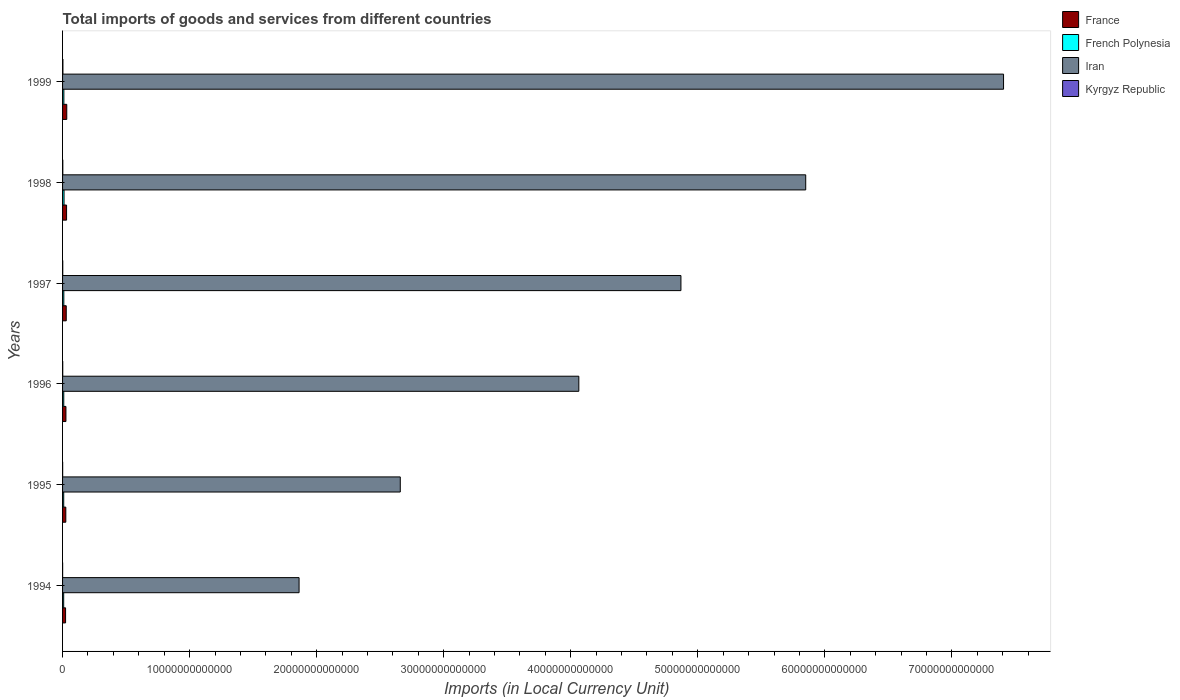Are the number of bars on each tick of the Y-axis equal?
Provide a succinct answer. Yes. How many bars are there on the 4th tick from the top?
Keep it short and to the point. 4. How many bars are there on the 3rd tick from the bottom?
Make the answer very short. 4. What is the Amount of goods and services imports in Iran in 1994?
Offer a terse response. 1.86e+13. Across all years, what is the maximum Amount of goods and services imports in Iran?
Offer a very short reply. 7.41e+13. Across all years, what is the minimum Amount of goods and services imports in Iran?
Provide a succinct answer. 1.86e+13. In which year was the Amount of goods and services imports in Iran maximum?
Provide a short and direct response. 1999. What is the total Amount of goods and services imports in Kyrgyz Republic in the graph?
Keep it short and to the point. 8.67e+1. What is the difference between the Amount of goods and services imports in Iran in 1995 and that in 1999?
Offer a terse response. -4.75e+13. What is the difference between the Amount of goods and services imports in French Polynesia in 1997 and the Amount of goods and services imports in Kyrgyz Republic in 1998?
Keep it short and to the point. 7.95e+1. What is the average Amount of goods and services imports in French Polynesia per year?
Make the answer very short. 9.87e+1. In the year 1995, what is the difference between the Amount of goods and services imports in Kyrgyz Republic and Amount of goods and services imports in Iran?
Offer a terse response. -2.66e+13. What is the ratio of the Amount of goods and services imports in Kyrgyz Republic in 1995 to that in 1999?
Give a very brief answer. 0.25. What is the difference between the highest and the second highest Amount of goods and services imports in Kyrgyz Republic?
Ensure brevity in your answer.  7.95e+09. What is the difference between the highest and the lowest Amount of goods and services imports in France?
Make the answer very short. 9.37e+1. What does the 1st bar from the top in 1998 represents?
Give a very brief answer. Kyrgyz Republic. What does the 2nd bar from the bottom in 1996 represents?
Provide a succinct answer. French Polynesia. Is it the case that in every year, the sum of the Amount of goods and services imports in Kyrgyz Republic and Amount of goods and services imports in Iran is greater than the Amount of goods and services imports in French Polynesia?
Provide a short and direct response. Yes. How many bars are there?
Provide a succinct answer. 24. Are all the bars in the graph horizontal?
Offer a very short reply. Yes. What is the difference between two consecutive major ticks on the X-axis?
Make the answer very short. 1.00e+13. Are the values on the major ticks of X-axis written in scientific E-notation?
Provide a short and direct response. No. How many legend labels are there?
Ensure brevity in your answer.  4. How are the legend labels stacked?
Your answer should be very brief. Vertical. What is the title of the graph?
Give a very brief answer. Total imports of goods and services from different countries. What is the label or title of the X-axis?
Make the answer very short. Imports (in Local Currency Unit). What is the label or title of the Y-axis?
Offer a very short reply. Years. What is the Imports (in Local Currency Unit) of France in 1994?
Your response must be concise. 2.37e+11. What is the Imports (in Local Currency Unit) in French Polynesia in 1994?
Your answer should be very brief. 8.79e+1. What is the Imports (in Local Currency Unit) in Iran in 1994?
Offer a terse response. 1.86e+13. What is the Imports (in Local Currency Unit) in Kyrgyz Republic in 1994?
Offer a very short reply. 4.82e+09. What is the Imports (in Local Currency Unit) in France in 1995?
Your response must be concise. 2.56e+11. What is the Imports (in Local Currency Unit) in French Polynesia in 1995?
Make the answer very short. 9.12e+1. What is the Imports (in Local Currency Unit) of Iran in 1995?
Ensure brevity in your answer.  2.66e+13. What is the Imports (in Local Currency Unit) in Kyrgyz Republic in 1995?
Provide a short and direct response. 6.84e+09. What is the Imports (in Local Currency Unit) of France in 1996?
Offer a terse response. 2.66e+11. What is the Imports (in Local Currency Unit) of French Polynesia in 1996?
Provide a short and direct response. 9.45e+1. What is the Imports (in Local Currency Unit) in Iran in 1996?
Offer a very short reply. 4.06e+13. What is the Imports (in Local Currency Unit) of Kyrgyz Republic in 1996?
Ensure brevity in your answer.  1.32e+1. What is the Imports (in Local Currency Unit) in France in 1997?
Provide a short and direct response. 2.90e+11. What is the Imports (in Local Currency Unit) in French Polynesia in 1997?
Your response must be concise. 9.93e+1. What is the Imports (in Local Currency Unit) in Iran in 1997?
Keep it short and to the point. 4.87e+13. What is the Imports (in Local Currency Unit) of Kyrgyz Republic in 1997?
Offer a terse response. 1.42e+1. What is the Imports (in Local Currency Unit) of France in 1998?
Ensure brevity in your answer.  3.15e+11. What is the Imports (in Local Currency Unit) in French Polynesia in 1998?
Provide a succinct answer. 1.16e+11. What is the Imports (in Local Currency Unit) of Iran in 1998?
Give a very brief answer. 5.85e+13. What is the Imports (in Local Currency Unit) of Kyrgyz Republic in 1998?
Give a very brief answer. 1.98e+1. What is the Imports (in Local Currency Unit) in France in 1999?
Provide a succinct answer. 3.31e+11. What is the Imports (in Local Currency Unit) of French Polynesia in 1999?
Your response must be concise. 1.03e+11. What is the Imports (in Local Currency Unit) of Iran in 1999?
Provide a succinct answer. 7.41e+13. What is the Imports (in Local Currency Unit) of Kyrgyz Republic in 1999?
Your response must be concise. 2.78e+1. Across all years, what is the maximum Imports (in Local Currency Unit) in France?
Give a very brief answer. 3.31e+11. Across all years, what is the maximum Imports (in Local Currency Unit) in French Polynesia?
Provide a short and direct response. 1.16e+11. Across all years, what is the maximum Imports (in Local Currency Unit) in Iran?
Provide a short and direct response. 7.41e+13. Across all years, what is the maximum Imports (in Local Currency Unit) of Kyrgyz Republic?
Ensure brevity in your answer.  2.78e+1. Across all years, what is the minimum Imports (in Local Currency Unit) in France?
Your answer should be compact. 2.37e+11. Across all years, what is the minimum Imports (in Local Currency Unit) of French Polynesia?
Keep it short and to the point. 8.79e+1. Across all years, what is the minimum Imports (in Local Currency Unit) in Iran?
Offer a terse response. 1.86e+13. Across all years, what is the minimum Imports (in Local Currency Unit) in Kyrgyz Republic?
Ensure brevity in your answer.  4.82e+09. What is the total Imports (in Local Currency Unit) in France in the graph?
Your response must be concise. 1.70e+12. What is the total Imports (in Local Currency Unit) of French Polynesia in the graph?
Give a very brief answer. 5.92e+11. What is the total Imports (in Local Currency Unit) in Iran in the graph?
Your answer should be compact. 2.67e+14. What is the total Imports (in Local Currency Unit) of Kyrgyz Republic in the graph?
Your answer should be compact. 8.67e+1. What is the difference between the Imports (in Local Currency Unit) of France in 1994 and that in 1995?
Make the answer very short. -1.82e+1. What is the difference between the Imports (in Local Currency Unit) in French Polynesia in 1994 and that in 1995?
Provide a succinct answer. -3.31e+09. What is the difference between the Imports (in Local Currency Unit) in Iran in 1994 and that in 1995?
Give a very brief answer. -7.97e+12. What is the difference between the Imports (in Local Currency Unit) in Kyrgyz Republic in 1994 and that in 1995?
Offer a very short reply. -2.02e+09. What is the difference between the Imports (in Local Currency Unit) of France in 1994 and that in 1996?
Provide a succinct answer. -2.84e+1. What is the difference between the Imports (in Local Currency Unit) of French Polynesia in 1994 and that in 1996?
Offer a very short reply. -6.61e+09. What is the difference between the Imports (in Local Currency Unit) of Iran in 1994 and that in 1996?
Your answer should be very brief. -2.20e+13. What is the difference between the Imports (in Local Currency Unit) of Kyrgyz Republic in 1994 and that in 1996?
Offer a very short reply. -8.42e+09. What is the difference between the Imports (in Local Currency Unit) of France in 1994 and that in 1997?
Your answer should be compact. -5.29e+1. What is the difference between the Imports (in Local Currency Unit) of French Polynesia in 1994 and that in 1997?
Provide a succinct answer. -1.14e+1. What is the difference between the Imports (in Local Currency Unit) of Iran in 1994 and that in 1997?
Offer a very short reply. -3.01e+13. What is the difference between the Imports (in Local Currency Unit) of Kyrgyz Republic in 1994 and that in 1997?
Provide a short and direct response. -9.36e+09. What is the difference between the Imports (in Local Currency Unit) in France in 1994 and that in 1998?
Offer a terse response. -7.79e+1. What is the difference between the Imports (in Local Currency Unit) in French Polynesia in 1994 and that in 1998?
Your response must be concise. -2.85e+1. What is the difference between the Imports (in Local Currency Unit) of Iran in 1994 and that in 1998?
Provide a short and direct response. -3.99e+13. What is the difference between the Imports (in Local Currency Unit) of Kyrgyz Republic in 1994 and that in 1998?
Make the answer very short. -1.50e+1. What is the difference between the Imports (in Local Currency Unit) in France in 1994 and that in 1999?
Give a very brief answer. -9.37e+1. What is the difference between the Imports (in Local Currency Unit) of French Polynesia in 1994 and that in 1999?
Make the answer very short. -1.51e+1. What is the difference between the Imports (in Local Currency Unit) of Iran in 1994 and that in 1999?
Keep it short and to the point. -5.54e+13. What is the difference between the Imports (in Local Currency Unit) in Kyrgyz Republic in 1994 and that in 1999?
Give a very brief answer. -2.30e+1. What is the difference between the Imports (in Local Currency Unit) in France in 1995 and that in 1996?
Offer a terse response. -1.02e+1. What is the difference between the Imports (in Local Currency Unit) in French Polynesia in 1995 and that in 1996?
Give a very brief answer. -3.31e+09. What is the difference between the Imports (in Local Currency Unit) in Iran in 1995 and that in 1996?
Provide a short and direct response. -1.41e+13. What is the difference between the Imports (in Local Currency Unit) in Kyrgyz Republic in 1995 and that in 1996?
Keep it short and to the point. -6.40e+09. What is the difference between the Imports (in Local Currency Unit) of France in 1995 and that in 1997?
Offer a very short reply. -3.47e+1. What is the difference between the Imports (in Local Currency Unit) of French Polynesia in 1995 and that in 1997?
Ensure brevity in your answer.  -8.13e+09. What is the difference between the Imports (in Local Currency Unit) of Iran in 1995 and that in 1997?
Offer a terse response. -2.21e+13. What is the difference between the Imports (in Local Currency Unit) in Kyrgyz Republic in 1995 and that in 1997?
Provide a short and direct response. -7.33e+09. What is the difference between the Imports (in Local Currency Unit) of France in 1995 and that in 1998?
Make the answer very short. -5.98e+1. What is the difference between the Imports (in Local Currency Unit) of French Polynesia in 1995 and that in 1998?
Your answer should be compact. -2.52e+1. What is the difference between the Imports (in Local Currency Unit) in Iran in 1995 and that in 1998?
Offer a terse response. -3.19e+13. What is the difference between the Imports (in Local Currency Unit) in Kyrgyz Republic in 1995 and that in 1998?
Give a very brief answer. -1.30e+1. What is the difference between the Imports (in Local Currency Unit) of France in 1995 and that in 1999?
Offer a very short reply. -7.55e+1. What is the difference between the Imports (in Local Currency Unit) in French Polynesia in 1995 and that in 1999?
Make the answer very short. -1.18e+1. What is the difference between the Imports (in Local Currency Unit) of Iran in 1995 and that in 1999?
Provide a succinct answer. -4.75e+13. What is the difference between the Imports (in Local Currency Unit) of Kyrgyz Republic in 1995 and that in 1999?
Ensure brevity in your answer.  -2.09e+1. What is the difference between the Imports (in Local Currency Unit) of France in 1996 and that in 1997?
Give a very brief answer. -2.45e+1. What is the difference between the Imports (in Local Currency Unit) in French Polynesia in 1996 and that in 1997?
Provide a short and direct response. -4.82e+09. What is the difference between the Imports (in Local Currency Unit) in Iran in 1996 and that in 1997?
Ensure brevity in your answer.  -8.04e+12. What is the difference between the Imports (in Local Currency Unit) in Kyrgyz Republic in 1996 and that in 1997?
Provide a short and direct response. -9.40e+08. What is the difference between the Imports (in Local Currency Unit) in France in 1996 and that in 1998?
Give a very brief answer. -4.96e+1. What is the difference between the Imports (in Local Currency Unit) in French Polynesia in 1996 and that in 1998?
Your answer should be very brief. -2.19e+1. What is the difference between the Imports (in Local Currency Unit) of Iran in 1996 and that in 1998?
Make the answer very short. -1.79e+13. What is the difference between the Imports (in Local Currency Unit) of Kyrgyz Republic in 1996 and that in 1998?
Ensure brevity in your answer.  -6.60e+09. What is the difference between the Imports (in Local Currency Unit) of France in 1996 and that in 1999?
Provide a succinct answer. -6.53e+1. What is the difference between the Imports (in Local Currency Unit) of French Polynesia in 1996 and that in 1999?
Provide a succinct answer. -8.49e+09. What is the difference between the Imports (in Local Currency Unit) of Iran in 1996 and that in 1999?
Offer a very short reply. -3.34e+13. What is the difference between the Imports (in Local Currency Unit) in Kyrgyz Republic in 1996 and that in 1999?
Your answer should be very brief. -1.45e+1. What is the difference between the Imports (in Local Currency Unit) in France in 1997 and that in 1998?
Provide a succinct answer. -2.50e+1. What is the difference between the Imports (in Local Currency Unit) of French Polynesia in 1997 and that in 1998?
Provide a succinct answer. -1.71e+1. What is the difference between the Imports (in Local Currency Unit) of Iran in 1997 and that in 1998?
Your answer should be very brief. -9.82e+12. What is the difference between the Imports (in Local Currency Unit) in Kyrgyz Republic in 1997 and that in 1998?
Offer a terse response. -5.66e+09. What is the difference between the Imports (in Local Currency Unit) of France in 1997 and that in 1999?
Give a very brief answer. -4.08e+1. What is the difference between the Imports (in Local Currency Unit) of French Polynesia in 1997 and that in 1999?
Your answer should be very brief. -3.67e+09. What is the difference between the Imports (in Local Currency Unit) of Iran in 1997 and that in 1999?
Your answer should be very brief. -2.54e+13. What is the difference between the Imports (in Local Currency Unit) in Kyrgyz Republic in 1997 and that in 1999?
Make the answer very short. -1.36e+1. What is the difference between the Imports (in Local Currency Unit) of France in 1998 and that in 1999?
Keep it short and to the point. -1.57e+1. What is the difference between the Imports (in Local Currency Unit) of French Polynesia in 1998 and that in 1999?
Your answer should be very brief. 1.34e+1. What is the difference between the Imports (in Local Currency Unit) in Iran in 1998 and that in 1999?
Ensure brevity in your answer.  -1.56e+13. What is the difference between the Imports (in Local Currency Unit) in Kyrgyz Republic in 1998 and that in 1999?
Provide a succinct answer. -7.95e+09. What is the difference between the Imports (in Local Currency Unit) in France in 1994 and the Imports (in Local Currency Unit) in French Polynesia in 1995?
Your response must be concise. 1.46e+11. What is the difference between the Imports (in Local Currency Unit) of France in 1994 and the Imports (in Local Currency Unit) of Iran in 1995?
Offer a terse response. -2.63e+13. What is the difference between the Imports (in Local Currency Unit) of France in 1994 and the Imports (in Local Currency Unit) of Kyrgyz Republic in 1995?
Provide a short and direct response. 2.31e+11. What is the difference between the Imports (in Local Currency Unit) in French Polynesia in 1994 and the Imports (in Local Currency Unit) in Iran in 1995?
Ensure brevity in your answer.  -2.65e+13. What is the difference between the Imports (in Local Currency Unit) in French Polynesia in 1994 and the Imports (in Local Currency Unit) in Kyrgyz Republic in 1995?
Keep it short and to the point. 8.10e+1. What is the difference between the Imports (in Local Currency Unit) of Iran in 1994 and the Imports (in Local Currency Unit) of Kyrgyz Republic in 1995?
Your response must be concise. 1.86e+13. What is the difference between the Imports (in Local Currency Unit) in France in 1994 and the Imports (in Local Currency Unit) in French Polynesia in 1996?
Your answer should be compact. 1.43e+11. What is the difference between the Imports (in Local Currency Unit) of France in 1994 and the Imports (in Local Currency Unit) of Iran in 1996?
Offer a very short reply. -4.04e+13. What is the difference between the Imports (in Local Currency Unit) in France in 1994 and the Imports (in Local Currency Unit) in Kyrgyz Republic in 1996?
Ensure brevity in your answer.  2.24e+11. What is the difference between the Imports (in Local Currency Unit) in French Polynesia in 1994 and the Imports (in Local Currency Unit) in Iran in 1996?
Ensure brevity in your answer.  -4.05e+13. What is the difference between the Imports (in Local Currency Unit) in French Polynesia in 1994 and the Imports (in Local Currency Unit) in Kyrgyz Republic in 1996?
Make the answer very short. 7.46e+1. What is the difference between the Imports (in Local Currency Unit) of Iran in 1994 and the Imports (in Local Currency Unit) of Kyrgyz Republic in 1996?
Ensure brevity in your answer.  1.86e+13. What is the difference between the Imports (in Local Currency Unit) of France in 1994 and the Imports (in Local Currency Unit) of French Polynesia in 1997?
Give a very brief answer. 1.38e+11. What is the difference between the Imports (in Local Currency Unit) in France in 1994 and the Imports (in Local Currency Unit) in Iran in 1997?
Your response must be concise. -4.84e+13. What is the difference between the Imports (in Local Currency Unit) in France in 1994 and the Imports (in Local Currency Unit) in Kyrgyz Republic in 1997?
Provide a short and direct response. 2.23e+11. What is the difference between the Imports (in Local Currency Unit) in French Polynesia in 1994 and the Imports (in Local Currency Unit) in Iran in 1997?
Make the answer very short. -4.86e+13. What is the difference between the Imports (in Local Currency Unit) of French Polynesia in 1994 and the Imports (in Local Currency Unit) of Kyrgyz Republic in 1997?
Your answer should be compact. 7.37e+1. What is the difference between the Imports (in Local Currency Unit) in Iran in 1994 and the Imports (in Local Currency Unit) in Kyrgyz Republic in 1997?
Ensure brevity in your answer.  1.86e+13. What is the difference between the Imports (in Local Currency Unit) of France in 1994 and the Imports (in Local Currency Unit) of French Polynesia in 1998?
Ensure brevity in your answer.  1.21e+11. What is the difference between the Imports (in Local Currency Unit) of France in 1994 and the Imports (in Local Currency Unit) of Iran in 1998?
Keep it short and to the point. -5.83e+13. What is the difference between the Imports (in Local Currency Unit) of France in 1994 and the Imports (in Local Currency Unit) of Kyrgyz Republic in 1998?
Ensure brevity in your answer.  2.18e+11. What is the difference between the Imports (in Local Currency Unit) in French Polynesia in 1994 and the Imports (in Local Currency Unit) in Iran in 1998?
Your answer should be very brief. -5.84e+13. What is the difference between the Imports (in Local Currency Unit) of French Polynesia in 1994 and the Imports (in Local Currency Unit) of Kyrgyz Republic in 1998?
Offer a terse response. 6.80e+1. What is the difference between the Imports (in Local Currency Unit) in Iran in 1994 and the Imports (in Local Currency Unit) in Kyrgyz Republic in 1998?
Your answer should be very brief. 1.86e+13. What is the difference between the Imports (in Local Currency Unit) of France in 1994 and the Imports (in Local Currency Unit) of French Polynesia in 1999?
Keep it short and to the point. 1.34e+11. What is the difference between the Imports (in Local Currency Unit) of France in 1994 and the Imports (in Local Currency Unit) of Iran in 1999?
Make the answer very short. -7.38e+13. What is the difference between the Imports (in Local Currency Unit) in France in 1994 and the Imports (in Local Currency Unit) in Kyrgyz Republic in 1999?
Offer a very short reply. 2.10e+11. What is the difference between the Imports (in Local Currency Unit) in French Polynesia in 1994 and the Imports (in Local Currency Unit) in Iran in 1999?
Provide a succinct answer. -7.40e+13. What is the difference between the Imports (in Local Currency Unit) in French Polynesia in 1994 and the Imports (in Local Currency Unit) in Kyrgyz Republic in 1999?
Offer a very short reply. 6.01e+1. What is the difference between the Imports (in Local Currency Unit) in Iran in 1994 and the Imports (in Local Currency Unit) in Kyrgyz Republic in 1999?
Ensure brevity in your answer.  1.86e+13. What is the difference between the Imports (in Local Currency Unit) of France in 1995 and the Imports (in Local Currency Unit) of French Polynesia in 1996?
Provide a short and direct response. 1.61e+11. What is the difference between the Imports (in Local Currency Unit) of France in 1995 and the Imports (in Local Currency Unit) of Iran in 1996?
Your answer should be very brief. -4.04e+13. What is the difference between the Imports (in Local Currency Unit) of France in 1995 and the Imports (in Local Currency Unit) of Kyrgyz Republic in 1996?
Provide a succinct answer. 2.42e+11. What is the difference between the Imports (in Local Currency Unit) in French Polynesia in 1995 and the Imports (in Local Currency Unit) in Iran in 1996?
Your answer should be very brief. -4.05e+13. What is the difference between the Imports (in Local Currency Unit) in French Polynesia in 1995 and the Imports (in Local Currency Unit) in Kyrgyz Republic in 1996?
Offer a terse response. 7.79e+1. What is the difference between the Imports (in Local Currency Unit) of Iran in 1995 and the Imports (in Local Currency Unit) of Kyrgyz Republic in 1996?
Make the answer very short. 2.66e+13. What is the difference between the Imports (in Local Currency Unit) in France in 1995 and the Imports (in Local Currency Unit) in French Polynesia in 1997?
Offer a terse response. 1.56e+11. What is the difference between the Imports (in Local Currency Unit) in France in 1995 and the Imports (in Local Currency Unit) in Iran in 1997?
Ensure brevity in your answer.  -4.84e+13. What is the difference between the Imports (in Local Currency Unit) of France in 1995 and the Imports (in Local Currency Unit) of Kyrgyz Republic in 1997?
Provide a short and direct response. 2.41e+11. What is the difference between the Imports (in Local Currency Unit) in French Polynesia in 1995 and the Imports (in Local Currency Unit) in Iran in 1997?
Provide a succinct answer. -4.86e+13. What is the difference between the Imports (in Local Currency Unit) of French Polynesia in 1995 and the Imports (in Local Currency Unit) of Kyrgyz Republic in 1997?
Your answer should be compact. 7.70e+1. What is the difference between the Imports (in Local Currency Unit) in Iran in 1995 and the Imports (in Local Currency Unit) in Kyrgyz Republic in 1997?
Ensure brevity in your answer.  2.66e+13. What is the difference between the Imports (in Local Currency Unit) in France in 1995 and the Imports (in Local Currency Unit) in French Polynesia in 1998?
Ensure brevity in your answer.  1.39e+11. What is the difference between the Imports (in Local Currency Unit) of France in 1995 and the Imports (in Local Currency Unit) of Iran in 1998?
Give a very brief answer. -5.82e+13. What is the difference between the Imports (in Local Currency Unit) in France in 1995 and the Imports (in Local Currency Unit) in Kyrgyz Republic in 1998?
Ensure brevity in your answer.  2.36e+11. What is the difference between the Imports (in Local Currency Unit) in French Polynesia in 1995 and the Imports (in Local Currency Unit) in Iran in 1998?
Provide a succinct answer. -5.84e+13. What is the difference between the Imports (in Local Currency Unit) in French Polynesia in 1995 and the Imports (in Local Currency Unit) in Kyrgyz Republic in 1998?
Your answer should be very brief. 7.13e+1. What is the difference between the Imports (in Local Currency Unit) of Iran in 1995 and the Imports (in Local Currency Unit) of Kyrgyz Republic in 1998?
Your response must be concise. 2.66e+13. What is the difference between the Imports (in Local Currency Unit) of France in 1995 and the Imports (in Local Currency Unit) of French Polynesia in 1999?
Your response must be concise. 1.53e+11. What is the difference between the Imports (in Local Currency Unit) of France in 1995 and the Imports (in Local Currency Unit) of Iran in 1999?
Give a very brief answer. -7.38e+13. What is the difference between the Imports (in Local Currency Unit) of France in 1995 and the Imports (in Local Currency Unit) of Kyrgyz Republic in 1999?
Ensure brevity in your answer.  2.28e+11. What is the difference between the Imports (in Local Currency Unit) in French Polynesia in 1995 and the Imports (in Local Currency Unit) in Iran in 1999?
Your response must be concise. -7.40e+13. What is the difference between the Imports (in Local Currency Unit) in French Polynesia in 1995 and the Imports (in Local Currency Unit) in Kyrgyz Republic in 1999?
Your answer should be compact. 6.34e+1. What is the difference between the Imports (in Local Currency Unit) in Iran in 1995 and the Imports (in Local Currency Unit) in Kyrgyz Republic in 1999?
Ensure brevity in your answer.  2.66e+13. What is the difference between the Imports (in Local Currency Unit) of France in 1996 and the Imports (in Local Currency Unit) of French Polynesia in 1997?
Offer a terse response. 1.67e+11. What is the difference between the Imports (in Local Currency Unit) in France in 1996 and the Imports (in Local Currency Unit) in Iran in 1997?
Provide a succinct answer. -4.84e+13. What is the difference between the Imports (in Local Currency Unit) in France in 1996 and the Imports (in Local Currency Unit) in Kyrgyz Republic in 1997?
Your answer should be very brief. 2.52e+11. What is the difference between the Imports (in Local Currency Unit) of French Polynesia in 1996 and the Imports (in Local Currency Unit) of Iran in 1997?
Your response must be concise. -4.86e+13. What is the difference between the Imports (in Local Currency Unit) of French Polynesia in 1996 and the Imports (in Local Currency Unit) of Kyrgyz Republic in 1997?
Ensure brevity in your answer.  8.03e+1. What is the difference between the Imports (in Local Currency Unit) in Iran in 1996 and the Imports (in Local Currency Unit) in Kyrgyz Republic in 1997?
Provide a short and direct response. 4.06e+13. What is the difference between the Imports (in Local Currency Unit) in France in 1996 and the Imports (in Local Currency Unit) in French Polynesia in 1998?
Ensure brevity in your answer.  1.49e+11. What is the difference between the Imports (in Local Currency Unit) in France in 1996 and the Imports (in Local Currency Unit) in Iran in 1998?
Provide a short and direct response. -5.82e+13. What is the difference between the Imports (in Local Currency Unit) of France in 1996 and the Imports (in Local Currency Unit) of Kyrgyz Republic in 1998?
Keep it short and to the point. 2.46e+11. What is the difference between the Imports (in Local Currency Unit) in French Polynesia in 1996 and the Imports (in Local Currency Unit) in Iran in 1998?
Offer a terse response. -5.84e+13. What is the difference between the Imports (in Local Currency Unit) of French Polynesia in 1996 and the Imports (in Local Currency Unit) of Kyrgyz Republic in 1998?
Give a very brief answer. 7.46e+1. What is the difference between the Imports (in Local Currency Unit) of Iran in 1996 and the Imports (in Local Currency Unit) of Kyrgyz Republic in 1998?
Give a very brief answer. 4.06e+13. What is the difference between the Imports (in Local Currency Unit) in France in 1996 and the Imports (in Local Currency Unit) in French Polynesia in 1999?
Your response must be concise. 1.63e+11. What is the difference between the Imports (in Local Currency Unit) of France in 1996 and the Imports (in Local Currency Unit) of Iran in 1999?
Your answer should be very brief. -7.38e+13. What is the difference between the Imports (in Local Currency Unit) of France in 1996 and the Imports (in Local Currency Unit) of Kyrgyz Republic in 1999?
Your answer should be compact. 2.38e+11. What is the difference between the Imports (in Local Currency Unit) in French Polynesia in 1996 and the Imports (in Local Currency Unit) in Iran in 1999?
Offer a terse response. -7.40e+13. What is the difference between the Imports (in Local Currency Unit) of French Polynesia in 1996 and the Imports (in Local Currency Unit) of Kyrgyz Republic in 1999?
Your answer should be very brief. 6.67e+1. What is the difference between the Imports (in Local Currency Unit) in Iran in 1996 and the Imports (in Local Currency Unit) in Kyrgyz Republic in 1999?
Your answer should be very brief. 4.06e+13. What is the difference between the Imports (in Local Currency Unit) in France in 1997 and the Imports (in Local Currency Unit) in French Polynesia in 1998?
Offer a terse response. 1.74e+11. What is the difference between the Imports (in Local Currency Unit) of France in 1997 and the Imports (in Local Currency Unit) of Iran in 1998?
Provide a succinct answer. -5.82e+13. What is the difference between the Imports (in Local Currency Unit) of France in 1997 and the Imports (in Local Currency Unit) of Kyrgyz Republic in 1998?
Your answer should be compact. 2.71e+11. What is the difference between the Imports (in Local Currency Unit) in French Polynesia in 1997 and the Imports (in Local Currency Unit) in Iran in 1998?
Keep it short and to the point. -5.84e+13. What is the difference between the Imports (in Local Currency Unit) in French Polynesia in 1997 and the Imports (in Local Currency Unit) in Kyrgyz Republic in 1998?
Provide a succinct answer. 7.95e+1. What is the difference between the Imports (in Local Currency Unit) in Iran in 1997 and the Imports (in Local Currency Unit) in Kyrgyz Republic in 1998?
Ensure brevity in your answer.  4.87e+13. What is the difference between the Imports (in Local Currency Unit) in France in 1997 and the Imports (in Local Currency Unit) in French Polynesia in 1999?
Provide a succinct answer. 1.87e+11. What is the difference between the Imports (in Local Currency Unit) in France in 1997 and the Imports (in Local Currency Unit) in Iran in 1999?
Give a very brief answer. -7.38e+13. What is the difference between the Imports (in Local Currency Unit) of France in 1997 and the Imports (in Local Currency Unit) of Kyrgyz Republic in 1999?
Keep it short and to the point. 2.63e+11. What is the difference between the Imports (in Local Currency Unit) of French Polynesia in 1997 and the Imports (in Local Currency Unit) of Iran in 1999?
Offer a very short reply. -7.40e+13. What is the difference between the Imports (in Local Currency Unit) in French Polynesia in 1997 and the Imports (in Local Currency Unit) in Kyrgyz Republic in 1999?
Your answer should be very brief. 7.15e+1. What is the difference between the Imports (in Local Currency Unit) in Iran in 1997 and the Imports (in Local Currency Unit) in Kyrgyz Republic in 1999?
Keep it short and to the point. 4.86e+13. What is the difference between the Imports (in Local Currency Unit) of France in 1998 and the Imports (in Local Currency Unit) of French Polynesia in 1999?
Your response must be concise. 2.12e+11. What is the difference between the Imports (in Local Currency Unit) of France in 1998 and the Imports (in Local Currency Unit) of Iran in 1999?
Provide a succinct answer. -7.37e+13. What is the difference between the Imports (in Local Currency Unit) in France in 1998 and the Imports (in Local Currency Unit) in Kyrgyz Republic in 1999?
Provide a short and direct response. 2.88e+11. What is the difference between the Imports (in Local Currency Unit) in French Polynesia in 1998 and the Imports (in Local Currency Unit) in Iran in 1999?
Keep it short and to the point. -7.39e+13. What is the difference between the Imports (in Local Currency Unit) in French Polynesia in 1998 and the Imports (in Local Currency Unit) in Kyrgyz Republic in 1999?
Offer a very short reply. 8.86e+1. What is the difference between the Imports (in Local Currency Unit) of Iran in 1998 and the Imports (in Local Currency Unit) of Kyrgyz Republic in 1999?
Your answer should be very brief. 5.85e+13. What is the average Imports (in Local Currency Unit) of France per year?
Keep it short and to the point. 2.83e+11. What is the average Imports (in Local Currency Unit) of French Polynesia per year?
Your response must be concise. 9.87e+1. What is the average Imports (in Local Currency Unit) of Iran per year?
Make the answer very short. 4.45e+13. What is the average Imports (in Local Currency Unit) of Kyrgyz Republic per year?
Offer a very short reply. 1.44e+1. In the year 1994, what is the difference between the Imports (in Local Currency Unit) of France and Imports (in Local Currency Unit) of French Polynesia?
Provide a succinct answer. 1.50e+11. In the year 1994, what is the difference between the Imports (in Local Currency Unit) in France and Imports (in Local Currency Unit) in Iran?
Give a very brief answer. -1.84e+13. In the year 1994, what is the difference between the Imports (in Local Currency Unit) in France and Imports (in Local Currency Unit) in Kyrgyz Republic?
Provide a succinct answer. 2.33e+11. In the year 1994, what is the difference between the Imports (in Local Currency Unit) of French Polynesia and Imports (in Local Currency Unit) of Iran?
Offer a terse response. -1.85e+13. In the year 1994, what is the difference between the Imports (in Local Currency Unit) of French Polynesia and Imports (in Local Currency Unit) of Kyrgyz Republic?
Your answer should be very brief. 8.31e+1. In the year 1994, what is the difference between the Imports (in Local Currency Unit) of Iran and Imports (in Local Currency Unit) of Kyrgyz Republic?
Offer a very short reply. 1.86e+13. In the year 1995, what is the difference between the Imports (in Local Currency Unit) of France and Imports (in Local Currency Unit) of French Polynesia?
Provide a succinct answer. 1.64e+11. In the year 1995, what is the difference between the Imports (in Local Currency Unit) in France and Imports (in Local Currency Unit) in Iran?
Your answer should be compact. -2.63e+13. In the year 1995, what is the difference between the Imports (in Local Currency Unit) in France and Imports (in Local Currency Unit) in Kyrgyz Republic?
Your response must be concise. 2.49e+11. In the year 1995, what is the difference between the Imports (in Local Currency Unit) in French Polynesia and Imports (in Local Currency Unit) in Iran?
Your response must be concise. -2.65e+13. In the year 1995, what is the difference between the Imports (in Local Currency Unit) of French Polynesia and Imports (in Local Currency Unit) of Kyrgyz Republic?
Offer a terse response. 8.43e+1. In the year 1995, what is the difference between the Imports (in Local Currency Unit) in Iran and Imports (in Local Currency Unit) in Kyrgyz Republic?
Make the answer very short. 2.66e+13. In the year 1996, what is the difference between the Imports (in Local Currency Unit) of France and Imports (in Local Currency Unit) of French Polynesia?
Ensure brevity in your answer.  1.71e+11. In the year 1996, what is the difference between the Imports (in Local Currency Unit) in France and Imports (in Local Currency Unit) in Iran?
Your answer should be compact. -4.04e+13. In the year 1996, what is the difference between the Imports (in Local Currency Unit) of France and Imports (in Local Currency Unit) of Kyrgyz Republic?
Offer a terse response. 2.53e+11. In the year 1996, what is the difference between the Imports (in Local Currency Unit) in French Polynesia and Imports (in Local Currency Unit) in Iran?
Offer a terse response. -4.05e+13. In the year 1996, what is the difference between the Imports (in Local Currency Unit) in French Polynesia and Imports (in Local Currency Unit) in Kyrgyz Republic?
Give a very brief answer. 8.12e+1. In the year 1996, what is the difference between the Imports (in Local Currency Unit) in Iran and Imports (in Local Currency Unit) in Kyrgyz Republic?
Offer a very short reply. 4.06e+13. In the year 1997, what is the difference between the Imports (in Local Currency Unit) of France and Imports (in Local Currency Unit) of French Polynesia?
Your response must be concise. 1.91e+11. In the year 1997, what is the difference between the Imports (in Local Currency Unit) in France and Imports (in Local Currency Unit) in Iran?
Your answer should be very brief. -4.84e+13. In the year 1997, what is the difference between the Imports (in Local Currency Unit) in France and Imports (in Local Currency Unit) in Kyrgyz Republic?
Your response must be concise. 2.76e+11. In the year 1997, what is the difference between the Imports (in Local Currency Unit) of French Polynesia and Imports (in Local Currency Unit) of Iran?
Your answer should be compact. -4.86e+13. In the year 1997, what is the difference between the Imports (in Local Currency Unit) in French Polynesia and Imports (in Local Currency Unit) in Kyrgyz Republic?
Ensure brevity in your answer.  8.51e+1. In the year 1997, what is the difference between the Imports (in Local Currency Unit) in Iran and Imports (in Local Currency Unit) in Kyrgyz Republic?
Provide a succinct answer. 4.87e+13. In the year 1998, what is the difference between the Imports (in Local Currency Unit) in France and Imports (in Local Currency Unit) in French Polynesia?
Give a very brief answer. 1.99e+11. In the year 1998, what is the difference between the Imports (in Local Currency Unit) of France and Imports (in Local Currency Unit) of Iran?
Offer a terse response. -5.82e+13. In the year 1998, what is the difference between the Imports (in Local Currency Unit) in France and Imports (in Local Currency Unit) in Kyrgyz Republic?
Ensure brevity in your answer.  2.96e+11. In the year 1998, what is the difference between the Imports (in Local Currency Unit) in French Polynesia and Imports (in Local Currency Unit) in Iran?
Your answer should be very brief. -5.84e+13. In the year 1998, what is the difference between the Imports (in Local Currency Unit) in French Polynesia and Imports (in Local Currency Unit) in Kyrgyz Republic?
Your answer should be very brief. 9.65e+1. In the year 1998, what is the difference between the Imports (in Local Currency Unit) of Iran and Imports (in Local Currency Unit) of Kyrgyz Republic?
Provide a succinct answer. 5.85e+13. In the year 1999, what is the difference between the Imports (in Local Currency Unit) in France and Imports (in Local Currency Unit) in French Polynesia?
Ensure brevity in your answer.  2.28e+11. In the year 1999, what is the difference between the Imports (in Local Currency Unit) of France and Imports (in Local Currency Unit) of Iran?
Make the answer very short. -7.37e+13. In the year 1999, what is the difference between the Imports (in Local Currency Unit) in France and Imports (in Local Currency Unit) in Kyrgyz Republic?
Give a very brief answer. 3.03e+11. In the year 1999, what is the difference between the Imports (in Local Currency Unit) of French Polynesia and Imports (in Local Currency Unit) of Iran?
Your answer should be very brief. -7.40e+13. In the year 1999, what is the difference between the Imports (in Local Currency Unit) in French Polynesia and Imports (in Local Currency Unit) in Kyrgyz Republic?
Offer a very short reply. 7.52e+1. In the year 1999, what is the difference between the Imports (in Local Currency Unit) of Iran and Imports (in Local Currency Unit) of Kyrgyz Republic?
Your answer should be compact. 7.40e+13. What is the ratio of the Imports (in Local Currency Unit) of France in 1994 to that in 1995?
Provide a succinct answer. 0.93. What is the ratio of the Imports (in Local Currency Unit) of French Polynesia in 1994 to that in 1995?
Your answer should be very brief. 0.96. What is the ratio of the Imports (in Local Currency Unit) of Iran in 1994 to that in 1995?
Give a very brief answer. 0.7. What is the ratio of the Imports (in Local Currency Unit) in Kyrgyz Republic in 1994 to that in 1995?
Offer a terse response. 0.7. What is the ratio of the Imports (in Local Currency Unit) in France in 1994 to that in 1996?
Your answer should be very brief. 0.89. What is the ratio of the Imports (in Local Currency Unit) of Iran in 1994 to that in 1996?
Give a very brief answer. 0.46. What is the ratio of the Imports (in Local Currency Unit) in Kyrgyz Republic in 1994 to that in 1996?
Give a very brief answer. 0.36. What is the ratio of the Imports (in Local Currency Unit) in France in 1994 to that in 1997?
Offer a very short reply. 0.82. What is the ratio of the Imports (in Local Currency Unit) of French Polynesia in 1994 to that in 1997?
Offer a terse response. 0.88. What is the ratio of the Imports (in Local Currency Unit) of Iran in 1994 to that in 1997?
Offer a very short reply. 0.38. What is the ratio of the Imports (in Local Currency Unit) of Kyrgyz Republic in 1994 to that in 1997?
Make the answer very short. 0.34. What is the ratio of the Imports (in Local Currency Unit) of France in 1994 to that in 1998?
Provide a short and direct response. 0.75. What is the ratio of the Imports (in Local Currency Unit) of French Polynesia in 1994 to that in 1998?
Keep it short and to the point. 0.76. What is the ratio of the Imports (in Local Currency Unit) in Iran in 1994 to that in 1998?
Give a very brief answer. 0.32. What is the ratio of the Imports (in Local Currency Unit) of Kyrgyz Republic in 1994 to that in 1998?
Make the answer very short. 0.24. What is the ratio of the Imports (in Local Currency Unit) in France in 1994 to that in 1999?
Provide a succinct answer. 0.72. What is the ratio of the Imports (in Local Currency Unit) of French Polynesia in 1994 to that in 1999?
Your response must be concise. 0.85. What is the ratio of the Imports (in Local Currency Unit) in Iran in 1994 to that in 1999?
Provide a succinct answer. 0.25. What is the ratio of the Imports (in Local Currency Unit) of Kyrgyz Republic in 1994 to that in 1999?
Provide a succinct answer. 0.17. What is the ratio of the Imports (in Local Currency Unit) of France in 1995 to that in 1996?
Offer a terse response. 0.96. What is the ratio of the Imports (in Local Currency Unit) in French Polynesia in 1995 to that in 1996?
Give a very brief answer. 0.96. What is the ratio of the Imports (in Local Currency Unit) in Iran in 1995 to that in 1996?
Offer a terse response. 0.65. What is the ratio of the Imports (in Local Currency Unit) in Kyrgyz Republic in 1995 to that in 1996?
Offer a terse response. 0.52. What is the ratio of the Imports (in Local Currency Unit) of France in 1995 to that in 1997?
Keep it short and to the point. 0.88. What is the ratio of the Imports (in Local Currency Unit) in French Polynesia in 1995 to that in 1997?
Provide a succinct answer. 0.92. What is the ratio of the Imports (in Local Currency Unit) of Iran in 1995 to that in 1997?
Your answer should be very brief. 0.55. What is the ratio of the Imports (in Local Currency Unit) in Kyrgyz Republic in 1995 to that in 1997?
Make the answer very short. 0.48. What is the ratio of the Imports (in Local Currency Unit) of France in 1995 to that in 1998?
Your response must be concise. 0.81. What is the ratio of the Imports (in Local Currency Unit) of French Polynesia in 1995 to that in 1998?
Offer a terse response. 0.78. What is the ratio of the Imports (in Local Currency Unit) in Iran in 1995 to that in 1998?
Your answer should be compact. 0.45. What is the ratio of the Imports (in Local Currency Unit) in Kyrgyz Republic in 1995 to that in 1998?
Make the answer very short. 0.34. What is the ratio of the Imports (in Local Currency Unit) of France in 1995 to that in 1999?
Provide a short and direct response. 0.77. What is the ratio of the Imports (in Local Currency Unit) of French Polynesia in 1995 to that in 1999?
Provide a succinct answer. 0.89. What is the ratio of the Imports (in Local Currency Unit) in Iran in 1995 to that in 1999?
Your response must be concise. 0.36. What is the ratio of the Imports (in Local Currency Unit) of Kyrgyz Republic in 1995 to that in 1999?
Keep it short and to the point. 0.25. What is the ratio of the Imports (in Local Currency Unit) of France in 1996 to that in 1997?
Your answer should be very brief. 0.92. What is the ratio of the Imports (in Local Currency Unit) in French Polynesia in 1996 to that in 1997?
Your response must be concise. 0.95. What is the ratio of the Imports (in Local Currency Unit) in Iran in 1996 to that in 1997?
Provide a short and direct response. 0.83. What is the ratio of the Imports (in Local Currency Unit) of Kyrgyz Republic in 1996 to that in 1997?
Your answer should be very brief. 0.93. What is the ratio of the Imports (in Local Currency Unit) of France in 1996 to that in 1998?
Keep it short and to the point. 0.84. What is the ratio of the Imports (in Local Currency Unit) in French Polynesia in 1996 to that in 1998?
Keep it short and to the point. 0.81. What is the ratio of the Imports (in Local Currency Unit) of Iran in 1996 to that in 1998?
Give a very brief answer. 0.69. What is the ratio of the Imports (in Local Currency Unit) of Kyrgyz Republic in 1996 to that in 1998?
Ensure brevity in your answer.  0.67. What is the ratio of the Imports (in Local Currency Unit) of France in 1996 to that in 1999?
Give a very brief answer. 0.8. What is the ratio of the Imports (in Local Currency Unit) in French Polynesia in 1996 to that in 1999?
Your answer should be very brief. 0.92. What is the ratio of the Imports (in Local Currency Unit) in Iran in 1996 to that in 1999?
Provide a succinct answer. 0.55. What is the ratio of the Imports (in Local Currency Unit) in Kyrgyz Republic in 1996 to that in 1999?
Your answer should be very brief. 0.48. What is the ratio of the Imports (in Local Currency Unit) of France in 1997 to that in 1998?
Your response must be concise. 0.92. What is the ratio of the Imports (in Local Currency Unit) in French Polynesia in 1997 to that in 1998?
Your response must be concise. 0.85. What is the ratio of the Imports (in Local Currency Unit) in Iran in 1997 to that in 1998?
Keep it short and to the point. 0.83. What is the ratio of the Imports (in Local Currency Unit) of Kyrgyz Republic in 1997 to that in 1998?
Offer a terse response. 0.71. What is the ratio of the Imports (in Local Currency Unit) in France in 1997 to that in 1999?
Provide a short and direct response. 0.88. What is the ratio of the Imports (in Local Currency Unit) in French Polynesia in 1997 to that in 1999?
Give a very brief answer. 0.96. What is the ratio of the Imports (in Local Currency Unit) in Iran in 1997 to that in 1999?
Your response must be concise. 0.66. What is the ratio of the Imports (in Local Currency Unit) of Kyrgyz Republic in 1997 to that in 1999?
Your response must be concise. 0.51. What is the ratio of the Imports (in Local Currency Unit) in France in 1998 to that in 1999?
Offer a terse response. 0.95. What is the ratio of the Imports (in Local Currency Unit) of French Polynesia in 1998 to that in 1999?
Make the answer very short. 1.13. What is the ratio of the Imports (in Local Currency Unit) of Iran in 1998 to that in 1999?
Offer a very short reply. 0.79. What is the ratio of the Imports (in Local Currency Unit) in Kyrgyz Republic in 1998 to that in 1999?
Ensure brevity in your answer.  0.71. What is the difference between the highest and the second highest Imports (in Local Currency Unit) of France?
Give a very brief answer. 1.57e+1. What is the difference between the highest and the second highest Imports (in Local Currency Unit) of French Polynesia?
Keep it short and to the point. 1.34e+1. What is the difference between the highest and the second highest Imports (in Local Currency Unit) in Iran?
Provide a succinct answer. 1.56e+13. What is the difference between the highest and the second highest Imports (in Local Currency Unit) of Kyrgyz Republic?
Keep it short and to the point. 7.95e+09. What is the difference between the highest and the lowest Imports (in Local Currency Unit) of France?
Your answer should be compact. 9.37e+1. What is the difference between the highest and the lowest Imports (in Local Currency Unit) in French Polynesia?
Keep it short and to the point. 2.85e+1. What is the difference between the highest and the lowest Imports (in Local Currency Unit) in Iran?
Make the answer very short. 5.54e+13. What is the difference between the highest and the lowest Imports (in Local Currency Unit) in Kyrgyz Republic?
Provide a short and direct response. 2.30e+1. 